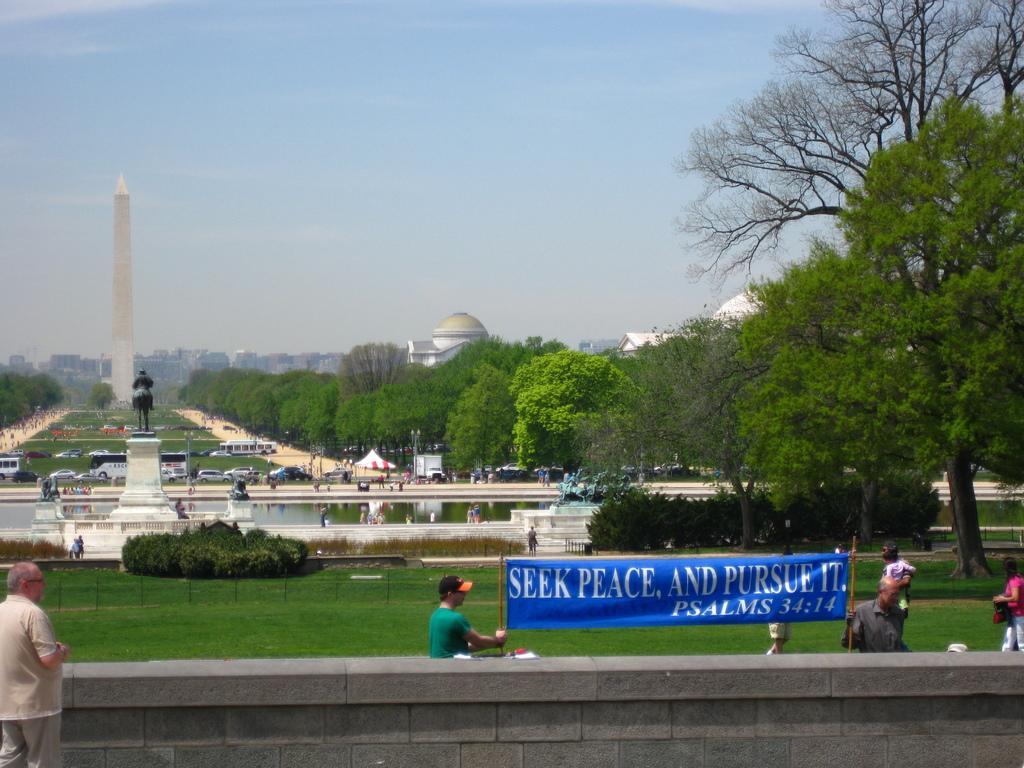Could you give a brief overview of what you see in this image? In this image, we can see buildings, trees, a tower, a statue and there are some vehicles on the road and we can see some people and there are some people holding a banner with some text and there are poles, a wall and there is water and we can see some tents. At the top, there is sky and at the bottom, there is ground. 